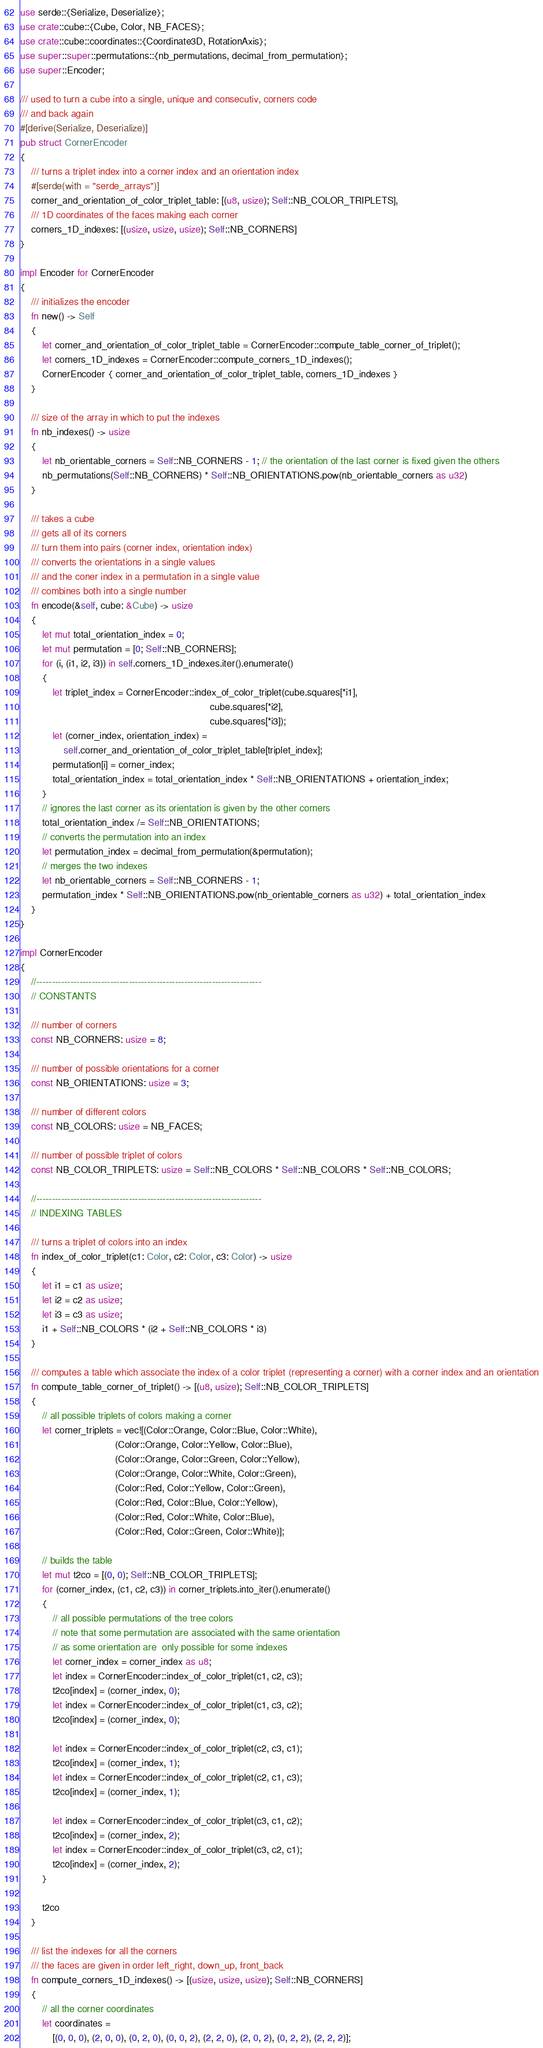Convert code to text. <code><loc_0><loc_0><loc_500><loc_500><_Rust_>use serde::{Serialize, Deserialize};
use crate::cube::{Cube, Color, NB_FACES};
use crate::cube::coordinates::{Coordinate3D, RotationAxis};
use super::super::permutations::{nb_permutations, decimal_from_permutation};
use super::Encoder;

/// used to turn a cube into a single, unique and consecutiv, corners code
/// and back again
#[derive(Serialize, Deserialize)]
pub struct CornerEncoder
{
    /// turns a triplet index into a corner index and an orientation index
    #[serde(with = "serde_arrays")]
    corner_and_orientation_of_color_triplet_table: [(u8, usize); Self::NB_COLOR_TRIPLETS],
    /// 1D coordinates of the faces making each corner
    corners_1D_indexes: [(usize, usize, usize); Self::NB_CORNERS]
}

impl Encoder for CornerEncoder
{
    /// initializes the encoder
    fn new() -> Self
    {
        let corner_and_orientation_of_color_triplet_table = CornerEncoder::compute_table_corner_of_triplet();
        let corners_1D_indexes = CornerEncoder::compute_corners_1D_indexes();
        CornerEncoder { corner_and_orientation_of_color_triplet_table, corners_1D_indexes }
    }

    /// size of the array in which to put the indexes
    fn nb_indexes() -> usize
    {
        let nb_orientable_corners = Self::NB_CORNERS - 1; // the orientation of the last corner is fixed given the others
        nb_permutations(Self::NB_CORNERS) * Self::NB_ORIENTATIONS.pow(nb_orientable_corners as u32)
    }

    /// takes a cube
    /// gets all of its corners
    /// turn them into pairs (corner index, orientation index)
    /// converts the orientations in a single values
    /// and the coner index in a permutation in a single value
    /// combines both into a single number
    fn encode(&self, cube: &Cube) -> usize
    {
        let mut total_orientation_index = 0;
        let mut permutation = [0; Self::NB_CORNERS];
        for (i, (i1, i2, i3)) in self.corners_1D_indexes.iter().enumerate()
        {
            let triplet_index = CornerEncoder::index_of_color_triplet(cube.squares[*i1],
                                                                      cube.squares[*i2],
                                                                      cube.squares[*i3]);
            let (corner_index, orientation_index) =
                self.corner_and_orientation_of_color_triplet_table[triplet_index];
            permutation[i] = corner_index;
            total_orientation_index = total_orientation_index * Self::NB_ORIENTATIONS + orientation_index;
        }
        // ignores the last corner as its orientation is given by the other corners
        total_orientation_index /= Self::NB_ORIENTATIONS;
        // converts the permutation into an index
        let permutation_index = decimal_from_permutation(&permutation);
        // merges the two indexes
        let nb_orientable_corners = Self::NB_CORNERS - 1;
        permutation_index * Self::NB_ORIENTATIONS.pow(nb_orientable_corners as u32) + total_orientation_index
    }
}

impl CornerEncoder
{
    //-------------------------------------------------------------------------
    // CONSTANTS

    /// number of corners
    const NB_CORNERS: usize = 8;

    /// number of possible orientations for a corner
    const NB_ORIENTATIONS: usize = 3;

    /// number of different colors
    const NB_COLORS: usize = NB_FACES;

    /// number of possible triplet of colors
    const NB_COLOR_TRIPLETS: usize = Self::NB_COLORS * Self::NB_COLORS * Self::NB_COLORS;

    //-------------------------------------------------------------------------
    // INDEXING TABLES

    /// turns a triplet of colors into an index
    fn index_of_color_triplet(c1: Color, c2: Color, c3: Color) -> usize
    {
        let i1 = c1 as usize;
        let i2 = c2 as usize;
        let i3 = c3 as usize;
        i1 + Self::NB_COLORS * (i2 + Self::NB_COLORS * i3)
    }

    /// computes a table which associate the index of a color triplet (representing a corner) with a corner index and an orientation
    fn compute_table_corner_of_triplet() -> [(u8, usize); Self::NB_COLOR_TRIPLETS]
    {
        // all possible triplets of colors making a corner
        let corner_triplets = vec![(Color::Orange, Color::Blue, Color::White),
                                   (Color::Orange, Color::Yellow, Color::Blue),
                                   (Color::Orange, Color::Green, Color::Yellow),
                                   (Color::Orange, Color::White, Color::Green),
                                   (Color::Red, Color::Yellow, Color::Green),
                                   (Color::Red, Color::Blue, Color::Yellow),
                                   (Color::Red, Color::White, Color::Blue),
                                   (Color::Red, Color::Green, Color::White)];

        // builds the table
        let mut t2co = [(0, 0); Self::NB_COLOR_TRIPLETS];
        for (corner_index, (c1, c2, c3)) in corner_triplets.into_iter().enumerate()
        {
            // all possible permutations of the tree colors
            // note that some permutation are associated with the same orientation
            // as some orientation are  only possible for some indexes
            let corner_index = corner_index as u8;
            let index = CornerEncoder::index_of_color_triplet(c1, c2, c3);
            t2co[index] = (corner_index, 0);
            let index = CornerEncoder::index_of_color_triplet(c1, c3, c2);
            t2co[index] = (corner_index, 0);

            let index = CornerEncoder::index_of_color_triplet(c2, c3, c1);
            t2co[index] = (corner_index, 1);
            let index = CornerEncoder::index_of_color_triplet(c2, c1, c3);
            t2co[index] = (corner_index, 1);

            let index = CornerEncoder::index_of_color_triplet(c3, c1, c2);
            t2co[index] = (corner_index, 2);
            let index = CornerEncoder::index_of_color_triplet(c3, c2, c1);
            t2co[index] = (corner_index, 2);
        }

        t2co
    }

    /// list the indexes for all the corners
    /// the faces are given in order left_right, down_up, front_back
    fn compute_corners_1D_indexes() -> [(usize, usize, usize); Self::NB_CORNERS]
    {
        // all the corner coordinates
        let coordinates =
            [(0, 0, 0), (2, 0, 0), (0, 2, 0), (0, 0, 2), (2, 2, 0), (2, 0, 2), (0, 2, 2), (2, 2, 2)];
</code> 